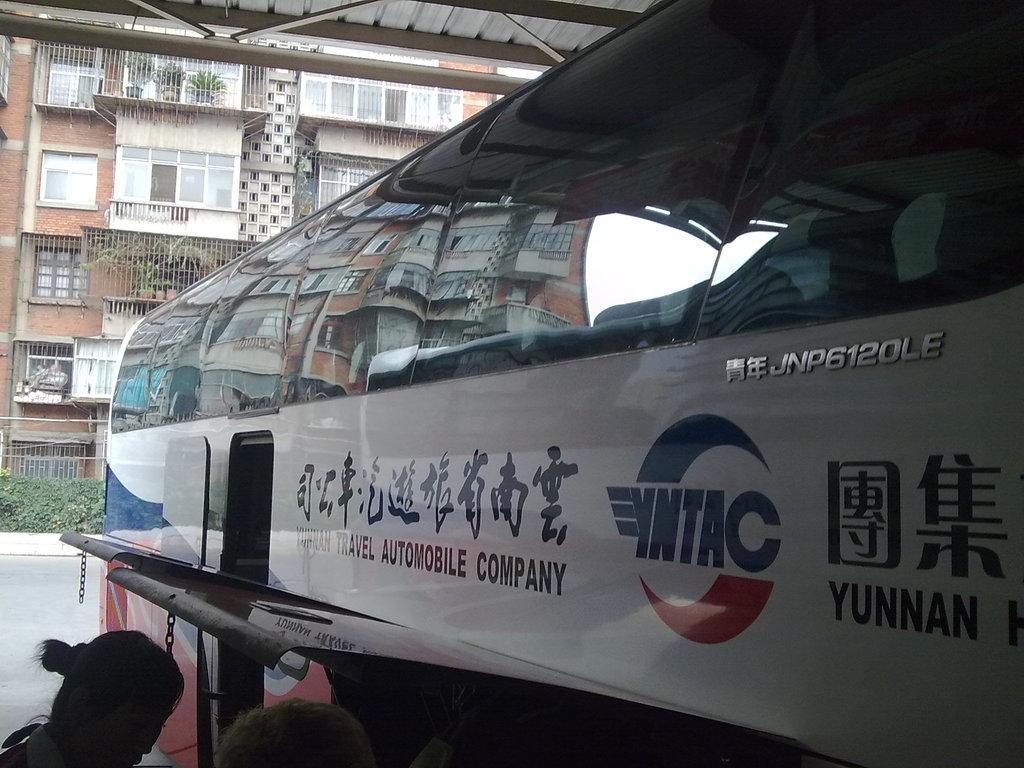Please provide a concise description of this image. In this image we can see mobile company bus which is of white, blue and red color and at the background of the image there are some buildings, plants, fencing. 